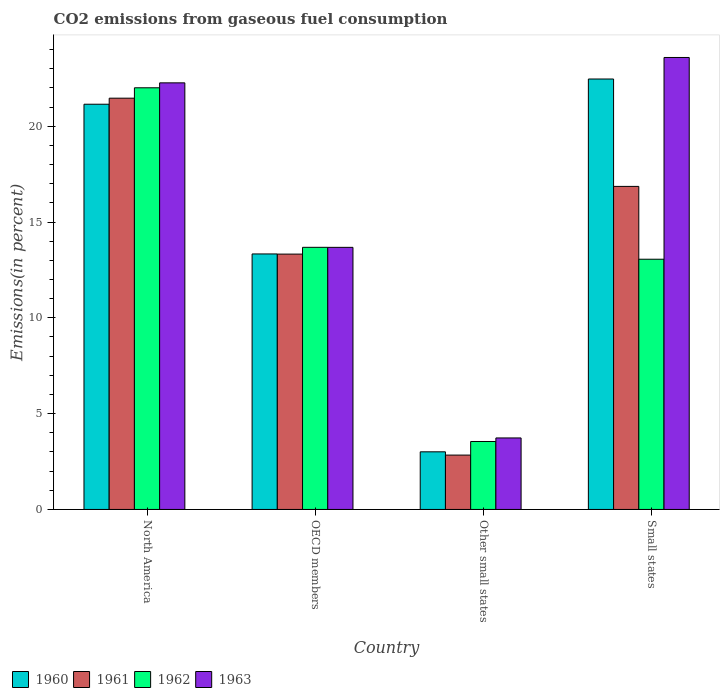How many groups of bars are there?
Your response must be concise. 4. Are the number of bars on each tick of the X-axis equal?
Provide a succinct answer. Yes. What is the label of the 4th group of bars from the left?
Provide a short and direct response. Small states. What is the total CO2 emitted in 1960 in Small states?
Keep it short and to the point. 22.46. Across all countries, what is the maximum total CO2 emitted in 1960?
Your answer should be compact. 22.46. Across all countries, what is the minimum total CO2 emitted in 1963?
Ensure brevity in your answer.  3.73. In which country was the total CO2 emitted in 1963 minimum?
Give a very brief answer. Other small states. What is the total total CO2 emitted in 1961 in the graph?
Offer a terse response. 54.48. What is the difference between the total CO2 emitted in 1963 in Other small states and that in Small states?
Your answer should be compact. -19.85. What is the difference between the total CO2 emitted in 1963 in North America and the total CO2 emitted in 1962 in Small states?
Your response must be concise. 9.2. What is the average total CO2 emitted in 1961 per country?
Your answer should be compact. 13.62. What is the difference between the total CO2 emitted of/in 1963 and total CO2 emitted of/in 1960 in Small states?
Your response must be concise. 1.12. In how many countries, is the total CO2 emitted in 1961 greater than 15 %?
Keep it short and to the point. 2. What is the ratio of the total CO2 emitted in 1963 in North America to that in Other small states?
Provide a short and direct response. 5.97. Is the total CO2 emitted in 1963 in North America less than that in OECD members?
Give a very brief answer. No. Is the difference between the total CO2 emitted in 1963 in North America and Other small states greater than the difference between the total CO2 emitted in 1960 in North America and Other small states?
Provide a short and direct response. Yes. What is the difference between the highest and the second highest total CO2 emitted in 1960?
Offer a terse response. -7.81. What is the difference between the highest and the lowest total CO2 emitted in 1960?
Your answer should be very brief. 19.46. In how many countries, is the total CO2 emitted in 1960 greater than the average total CO2 emitted in 1960 taken over all countries?
Provide a succinct answer. 2. Is the sum of the total CO2 emitted in 1963 in Other small states and Small states greater than the maximum total CO2 emitted in 1962 across all countries?
Keep it short and to the point. Yes. What does the 3rd bar from the left in Small states represents?
Offer a terse response. 1962. What does the 3rd bar from the right in North America represents?
Your answer should be compact. 1961. Are all the bars in the graph horizontal?
Ensure brevity in your answer.  No. What is the difference between two consecutive major ticks on the Y-axis?
Keep it short and to the point. 5. Are the values on the major ticks of Y-axis written in scientific E-notation?
Give a very brief answer. No. Does the graph contain any zero values?
Your answer should be very brief. No. How are the legend labels stacked?
Provide a short and direct response. Horizontal. What is the title of the graph?
Ensure brevity in your answer.  CO2 emissions from gaseous fuel consumption. Does "1999" appear as one of the legend labels in the graph?
Make the answer very short. No. What is the label or title of the X-axis?
Keep it short and to the point. Country. What is the label or title of the Y-axis?
Ensure brevity in your answer.  Emissions(in percent). What is the Emissions(in percent) in 1960 in North America?
Provide a succinct answer. 21.15. What is the Emissions(in percent) of 1961 in North America?
Your answer should be very brief. 21.46. What is the Emissions(in percent) in 1962 in North America?
Provide a short and direct response. 22. What is the Emissions(in percent) of 1963 in North America?
Ensure brevity in your answer.  22.26. What is the Emissions(in percent) in 1960 in OECD members?
Provide a succinct answer. 13.33. What is the Emissions(in percent) in 1961 in OECD members?
Give a very brief answer. 13.33. What is the Emissions(in percent) of 1962 in OECD members?
Your answer should be very brief. 13.68. What is the Emissions(in percent) in 1963 in OECD members?
Provide a succinct answer. 13.68. What is the Emissions(in percent) of 1960 in Other small states?
Keep it short and to the point. 3.01. What is the Emissions(in percent) in 1961 in Other small states?
Your response must be concise. 2.84. What is the Emissions(in percent) of 1962 in Other small states?
Make the answer very short. 3.55. What is the Emissions(in percent) in 1963 in Other small states?
Keep it short and to the point. 3.73. What is the Emissions(in percent) of 1960 in Small states?
Your answer should be compact. 22.46. What is the Emissions(in percent) of 1961 in Small states?
Provide a short and direct response. 16.86. What is the Emissions(in percent) in 1962 in Small states?
Make the answer very short. 13.06. What is the Emissions(in percent) in 1963 in Small states?
Your response must be concise. 23.59. Across all countries, what is the maximum Emissions(in percent) of 1960?
Make the answer very short. 22.46. Across all countries, what is the maximum Emissions(in percent) in 1961?
Provide a succinct answer. 21.46. Across all countries, what is the maximum Emissions(in percent) in 1962?
Your response must be concise. 22. Across all countries, what is the maximum Emissions(in percent) of 1963?
Provide a succinct answer. 23.59. Across all countries, what is the minimum Emissions(in percent) in 1960?
Ensure brevity in your answer.  3.01. Across all countries, what is the minimum Emissions(in percent) in 1961?
Make the answer very short. 2.84. Across all countries, what is the minimum Emissions(in percent) in 1962?
Provide a succinct answer. 3.55. Across all countries, what is the minimum Emissions(in percent) in 1963?
Your response must be concise. 3.73. What is the total Emissions(in percent) in 1960 in the graph?
Your answer should be very brief. 59.95. What is the total Emissions(in percent) of 1961 in the graph?
Offer a very short reply. 54.48. What is the total Emissions(in percent) in 1962 in the graph?
Make the answer very short. 52.29. What is the total Emissions(in percent) in 1963 in the graph?
Ensure brevity in your answer.  63.26. What is the difference between the Emissions(in percent) in 1960 in North America and that in OECD members?
Keep it short and to the point. 7.81. What is the difference between the Emissions(in percent) in 1961 in North America and that in OECD members?
Your response must be concise. 8.14. What is the difference between the Emissions(in percent) of 1962 in North America and that in OECD members?
Your response must be concise. 8.32. What is the difference between the Emissions(in percent) of 1963 in North America and that in OECD members?
Offer a very short reply. 8.58. What is the difference between the Emissions(in percent) in 1960 in North America and that in Other small states?
Provide a succinct answer. 18.14. What is the difference between the Emissions(in percent) in 1961 in North America and that in Other small states?
Your response must be concise. 18.62. What is the difference between the Emissions(in percent) in 1962 in North America and that in Other small states?
Ensure brevity in your answer.  18.46. What is the difference between the Emissions(in percent) in 1963 in North America and that in Other small states?
Keep it short and to the point. 18.53. What is the difference between the Emissions(in percent) in 1960 in North America and that in Small states?
Give a very brief answer. -1.32. What is the difference between the Emissions(in percent) of 1961 in North America and that in Small states?
Offer a terse response. 4.6. What is the difference between the Emissions(in percent) of 1962 in North America and that in Small states?
Your response must be concise. 8.95. What is the difference between the Emissions(in percent) of 1963 in North America and that in Small states?
Provide a short and direct response. -1.32. What is the difference between the Emissions(in percent) in 1960 in OECD members and that in Other small states?
Offer a terse response. 10.33. What is the difference between the Emissions(in percent) of 1961 in OECD members and that in Other small states?
Give a very brief answer. 10.49. What is the difference between the Emissions(in percent) of 1962 in OECD members and that in Other small states?
Keep it short and to the point. 10.13. What is the difference between the Emissions(in percent) of 1963 in OECD members and that in Other small states?
Ensure brevity in your answer.  9.95. What is the difference between the Emissions(in percent) in 1960 in OECD members and that in Small states?
Your answer should be compact. -9.13. What is the difference between the Emissions(in percent) of 1961 in OECD members and that in Small states?
Your answer should be compact. -3.53. What is the difference between the Emissions(in percent) of 1962 in OECD members and that in Small states?
Ensure brevity in your answer.  0.62. What is the difference between the Emissions(in percent) in 1963 in OECD members and that in Small states?
Give a very brief answer. -9.91. What is the difference between the Emissions(in percent) in 1960 in Other small states and that in Small states?
Provide a short and direct response. -19.45. What is the difference between the Emissions(in percent) in 1961 in Other small states and that in Small states?
Your answer should be compact. -14.02. What is the difference between the Emissions(in percent) of 1962 in Other small states and that in Small states?
Your answer should be very brief. -9.51. What is the difference between the Emissions(in percent) of 1963 in Other small states and that in Small states?
Give a very brief answer. -19.85. What is the difference between the Emissions(in percent) of 1960 in North America and the Emissions(in percent) of 1961 in OECD members?
Provide a succinct answer. 7.82. What is the difference between the Emissions(in percent) of 1960 in North America and the Emissions(in percent) of 1962 in OECD members?
Make the answer very short. 7.47. What is the difference between the Emissions(in percent) in 1960 in North America and the Emissions(in percent) in 1963 in OECD members?
Offer a terse response. 7.47. What is the difference between the Emissions(in percent) of 1961 in North America and the Emissions(in percent) of 1962 in OECD members?
Your response must be concise. 7.78. What is the difference between the Emissions(in percent) of 1961 in North America and the Emissions(in percent) of 1963 in OECD members?
Your response must be concise. 7.78. What is the difference between the Emissions(in percent) in 1962 in North America and the Emissions(in percent) in 1963 in OECD members?
Make the answer very short. 8.33. What is the difference between the Emissions(in percent) in 1960 in North America and the Emissions(in percent) in 1961 in Other small states?
Provide a succinct answer. 18.31. What is the difference between the Emissions(in percent) in 1960 in North America and the Emissions(in percent) in 1962 in Other small states?
Offer a terse response. 17.6. What is the difference between the Emissions(in percent) of 1960 in North America and the Emissions(in percent) of 1963 in Other small states?
Keep it short and to the point. 17.41. What is the difference between the Emissions(in percent) of 1961 in North America and the Emissions(in percent) of 1962 in Other small states?
Your answer should be very brief. 17.92. What is the difference between the Emissions(in percent) in 1961 in North America and the Emissions(in percent) in 1963 in Other small states?
Provide a succinct answer. 17.73. What is the difference between the Emissions(in percent) in 1962 in North America and the Emissions(in percent) in 1963 in Other small states?
Offer a very short reply. 18.27. What is the difference between the Emissions(in percent) of 1960 in North America and the Emissions(in percent) of 1961 in Small states?
Make the answer very short. 4.29. What is the difference between the Emissions(in percent) in 1960 in North America and the Emissions(in percent) in 1962 in Small states?
Your response must be concise. 8.09. What is the difference between the Emissions(in percent) in 1960 in North America and the Emissions(in percent) in 1963 in Small states?
Your answer should be compact. -2.44. What is the difference between the Emissions(in percent) of 1961 in North America and the Emissions(in percent) of 1962 in Small states?
Offer a very short reply. 8.4. What is the difference between the Emissions(in percent) of 1961 in North America and the Emissions(in percent) of 1963 in Small states?
Give a very brief answer. -2.12. What is the difference between the Emissions(in percent) of 1962 in North America and the Emissions(in percent) of 1963 in Small states?
Make the answer very short. -1.58. What is the difference between the Emissions(in percent) in 1960 in OECD members and the Emissions(in percent) in 1961 in Other small states?
Provide a short and direct response. 10.5. What is the difference between the Emissions(in percent) in 1960 in OECD members and the Emissions(in percent) in 1962 in Other small states?
Your answer should be compact. 9.79. What is the difference between the Emissions(in percent) of 1960 in OECD members and the Emissions(in percent) of 1963 in Other small states?
Your answer should be compact. 9.6. What is the difference between the Emissions(in percent) in 1961 in OECD members and the Emissions(in percent) in 1962 in Other small states?
Provide a succinct answer. 9.78. What is the difference between the Emissions(in percent) in 1961 in OECD members and the Emissions(in percent) in 1963 in Other small states?
Keep it short and to the point. 9.59. What is the difference between the Emissions(in percent) of 1962 in OECD members and the Emissions(in percent) of 1963 in Other small states?
Keep it short and to the point. 9.95. What is the difference between the Emissions(in percent) of 1960 in OECD members and the Emissions(in percent) of 1961 in Small states?
Provide a succinct answer. -3.52. What is the difference between the Emissions(in percent) of 1960 in OECD members and the Emissions(in percent) of 1962 in Small states?
Offer a very short reply. 0.28. What is the difference between the Emissions(in percent) in 1960 in OECD members and the Emissions(in percent) in 1963 in Small states?
Ensure brevity in your answer.  -10.25. What is the difference between the Emissions(in percent) of 1961 in OECD members and the Emissions(in percent) of 1962 in Small states?
Keep it short and to the point. 0.27. What is the difference between the Emissions(in percent) of 1961 in OECD members and the Emissions(in percent) of 1963 in Small states?
Provide a succinct answer. -10.26. What is the difference between the Emissions(in percent) in 1962 in OECD members and the Emissions(in percent) in 1963 in Small states?
Your response must be concise. -9.91. What is the difference between the Emissions(in percent) in 1960 in Other small states and the Emissions(in percent) in 1961 in Small states?
Offer a terse response. -13.85. What is the difference between the Emissions(in percent) of 1960 in Other small states and the Emissions(in percent) of 1962 in Small states?
Keep it short and to the point. -10.05. What is the difference between the Emissions(in percent) of 1960 in Other small states and the Emissions(in percent) of 1963 in Small states?
Ensure brevity in your answer.  -20.58. What is the difference between the Emissions(in percent) in 1961 in Other small states and the Emissions(in percent) in 1962 in Small states?
Provide a succinct answer. -10.22. What is the difference between the Emissions(in percent) in 1961 in Other small states and the Emissions(in percent) in 1963 in Small states?
Your response must be concise. -20.75. What is the difference between the Emissions(in percent) of 1962 in Other small states and the Emissions(in percent) of 1963 in Small states?
Ensure brevity in your answer.  -20.04. What is the average Emissions(in percent) of 1960 per country?
Offer a terse response. 14.99. What is the average Emissions(in percent) in 1961 per country?
Offer a terse response. 13.62. What is the average Emissions(in percent) in 1962 per country?
Ensure brevity in your answer.  13.07. What is the average Emissions(in percent) of 1963 per country?
Your answer should be compact. 15.81. What is the difference between the Emissions(in percent) of 1960 and Emissions(in percent) of 1961 in North America?
Provide a short and direct response. -0.32. What is the difference between the Emissions(in percent) of 1960 and Emissions(in percent) of 1962 in North America?
Offer a very short reply. -0.86. What is the difference between the Emissions(in percent) in 1960 and Emissions(in percent) in 1963 in North America?
Your response must be concise. -1.12. What is the difference between the Emissions(in percent) of 1961 and Emissions(in percent) of 1962 in North America?
Your response must be concise. -0.54. What is the difference between the Emissions(in percent) of 1962 and Emissions(in percent) of 1963 in North America?
Your answer should be compact. -0.26. What is the difference between the Emissions(in percent) in 1960 and Emissions(in percent) in 1961 in OECD members?
Your response must be concise. 0.01. What is the difference between the Emissions(in percent) in 1960 and Emissions(in percent) in 1962 in OECD members?
Keep it short and to the point. -0.35. What is the difference between the Emissions(in percent) in 1960 and Emissions(in percent) in 1963 in OECD members?
Ensure brevity in your answer.  -0.34. What is the difference between the Emissions(in percent) of 1961 and Emissions(in percent) of 1962 in OECD members?
Provide a short and direct response. -0.35. What is the difference between the Emissions(in percent) of 1961 and Emissions(in percent) of 1963 in OECD members?
Give a very brief answer. -0.35. What is the difference between the Emissions(in percent) of 1962 and Emissions(in percent) of 1963 in OECD members?
Offer a very short reply. 0. What is the difference between the Emissions(in percent) in 1960 and Emissions(in percent) in 1961 in Other small states?
Your response must be concise. 0.17. What is the difference between the Emissions(in percent) in 1960 and Emissions(in percent) in 1962 in Other small states?
Give a very brief answer. -0.54. What is the difference between the Emissions(in percent) in 1960 and Emissions(in percent) in 1963 in Other small states?
Provide a succinct answer. -0.72. What is the difference between the Emissions(in percent) of 1961 and Emissions(in percent) of 1962 in Other small states?
Provide a short and direct response. -0.71. What is the difference between the Emissions(in percent) of 1961 and Emissions(in percent) of 1963 in Other small states?
Provide a succinct answer. -0.89. What is the difference between the Emissions(in percent) in 1962 and Emissions(in percent) in 1963 in Other small states?
Ensure brevity in your answer.  -0.19. What is the difference between the Emissions(in percent) of 1960 and Emissions(in percent) of 1961 in Small states?
Provide a succinct answer. 5.6. What is the difference between the Emissions(in percent) of 1960 and Emissions(in percent) of 1962 in Small states?
Your response must be concise. 9.41. What is the difference between the Emissions(in percent) of 1960 and Emissions(in percent) of 1963 in Small states?
Your answer should be very brief. -1.12. What is the difference between the Emissions(in percent) of 1961 and Emissions(in percent) of 1962 in Small states?
Offer a terse response. 3.8. What is the difference between the Emissions(in percent) of 1961 and Emissions(in percent) of 1963 in Small states?
Ensure brevity in your answer.  -6.73. What is the difference between the Emissions(in percent) in 1962 and Emissions(in percent) in 1963 in Small states?
Provide a short and direct response. -10.53. What is the ratio of the Emissions(in percent) in 1960 in North America to that in OECD members?
Provide a short and direct response. 1.59. What is the ratio of the Emissions(in percent) of 1961 in North America to that in OECD members?
Keep it short and to the point. 1.61. What is the ratio of the Emissions(in percent) in 1962 in North America to that in OECD members?
Your response must be concise. 1.61. What is the ratio of the Emissions(in percent) in 1963 in North America to that in OECD members?
Your answer should be compact. 1.63. What is the ratio of the Emissions(in percent) in 1960 in North America to that in Other small states?
Make the answer very short. 7.03. What is the ratio of the Emissions(in percent) in 1961 in North America to that in Other small states?
Ensure brevity in your answer.  7.57. What is the ratio of the Emissions(in percent) of 1962 in North America to that in Other small states?
Your response must be concise. 6.21. What is the ratio of the Emissions(in percent) of 1963 in North America to that in Other small states?
Your response must be concise. 5.97. What is the ratio of the Emissions(in percent) in 1960 in North America to that in Small states?
Offer a very short reply. 0.94. What is the ratio of the Emissions(in percent) of 1961 in North America to that in Small states?
Your response must be concise. 1.27. What is the ratio of the Emissions(in percent) in 1962 in North America to that in Small states?
Your response must be concise. 1.69. What is the ratio of the Emissions(in percent) in 1963 in North America to that in Small states?
Make the answer very short. 0.94. What is the ratio of the Emissions(in percent) in 1960 in OECD members to that in Other small states?
Give a very brief answer. 4.43. What is the ratio of the Emissions(in percent) in 1961 in OECD members to that in Other small states?
Provide a succinct answer. 4.7. What is the ratio of the Emissions(in percent) in 1962 in OECD members to that in Other small states?
Keep it short and to the point. 3.86. What is the ratio of the Emissions(in percent) in 1963 in OECD members to that in Other small states?
Your answer should be compact. 3.67. What is the ratio of the Emissions(in percent) of 1960 in OECD members to that in Small states?
Your answer should be very brief. 0.59. What is the ratio of the Emissions(in percent) of 1961 in OECD members to that in Small states?
Provide a short and direct response. 0.79. What is the ratio of the Emissions(in percent) of 1962 in OECD members to that in Small states?
Your response must be concise. 1.05. What is the ratio of the Emissions(in percent) of 1963 in OECD members to that in Small states?
Offer a terse response. 0.58. What is the ratio of the Emissions(in percent) of 1960 in Other small states to that in Small states?
Your answer should be very brief. 0.13. What is the ratio of the Emissions(in percent) of 1961 in Other small states to that in Small states?
Keep it short and to the point. 0.17. What is the ratio of the Emissions(in percent) of 1962 in Other small states to that in Small states?
Your response must be concise. 0.27. What is the ratio of the Emissions(in percent) of 1963 in Other small states to that in Small states?
Your answer should be compact. 0.16. What is the difference between the highest and the second highest Emissions(in percent) in 1960?
Make the answer very short. 1.32. What is the difference between the highest and the second highest Emissions(in percent) in 1961?
Offer a terse response. 4.6. What is the difference between the highest and the second highest Emissions(in percent) of 1962?
Offer a very short reply. 8.32. What is the difference between the highest and the second highest Emissions(in percent) of 1963?
Offer a terse response. 1.32. What is the difference between the highest and the lowest Emissions(in percent) of 1960?
Your response must be concise. 19.45. What is the difference between the highest and the lowest Emissions(in percent) of 1961?
Ensure brevity in your answer.  18.62. What is the difference between the highest and the lowest Emissions(in percent) in 1962?
Provide a short and direct response. 18.46. What is the difference between the highest and the lowest Emissions(in percent) in 1963?
Offer a very short reply. 19.85. 